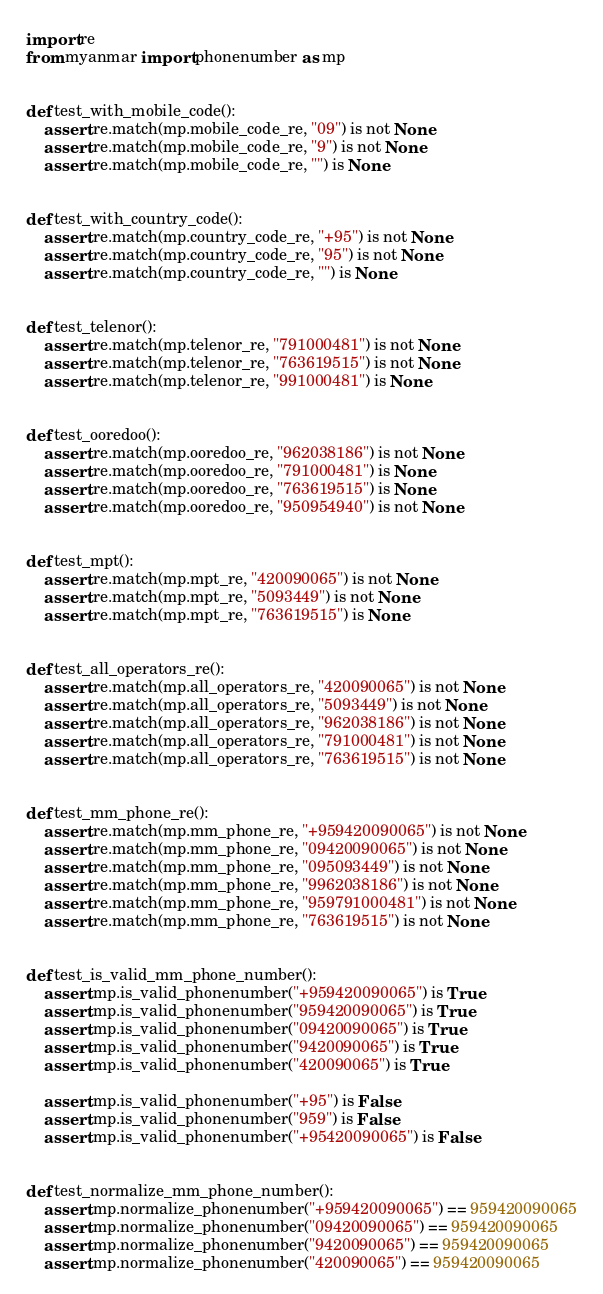Convert code to text. <code><loc_0><loc_0><loc_500><loc_500><_Python_>import re
from myanmar import phonenumber as mp


def test_with_mobile_code():
    assert re.match(mp.mobile_code_re, "09") is not None
    assert re.match(mp.mobile_code_re, "9") is not None
    assert re.match(mp.mobile_code_re, "") is None


def test_with_country_code():
    assert re.match(mp.country_code_re, "+95") is not None
    assert re.match(mp.country_code_re, "95") is not None
    assert re.match(mp.country_code_re, "") is None


def test_telenor():
    assert re.match(mp.telenor_re, "791000481") is not None
    assert re.match(mp.telenor_re, "763619515") is not None
    assert re.match(mp.telenor_re, "991000481") is None


def test_ooredoo():
    assert re.match(mp.ooredoo_re, "962038186") is not None
    assert re.match(mp.ooredoo_re, "791000481") is None
    assert re.match(mp.ooredoo_re, "763619515") is None
    assert re.match(mp.ooredoo_re, "950954940") is not None


def test_mpt():
    assert re.match(mp.mpt_re, "420090065") is not None
    assert re.match(mp.mpt_re, "5093449") is not None
    assert re.match(mp.mpt_re, "763619515") is None


def test_all_operators_re():
    assert re.match(mp.all_operators_re, "420090065") is not None
    assert re.match(mp.all_operators_re, "5093449") is not None
    assert re.match(mp.all_operators_re, "962038186") is not None
    assert re.match(mp.all_operators_re, "791000481") is not None
    assert re.match(mp.all_operators_re, "763619515") is not None


def test_mm_phone_re():
    assert re.match(mp.mm_phone_re, "+959420090065") is not None
    assert re.match(mp.mm_phone_re, "09420090065") is not None
    assert re.match(mp.mm_phone_re, "095093449") is not None
    assert re.match(mp.mm_phone_re, "9962038186") is not None
    assert re.match(mp.mm_phone_re, "959791000481") is not None
    assert re.match(mp.mm_phone_re, "763619515") is not None


def test_is_valid_mm_phone_number():
    assert mp.is_valid_phonenumber("+959420090065") is True
    assert mp.is_valid_phonenumber("959420090065") is True
    assert mp.is_valid_phonenumber("09420090065") is True
    assert mp.is_valid_phonenumber("9420090065") is True
    assert mp.is_valid_phonenumber("420090065") is True

    assert mp.is_valid_phonenumber("+95") is False
    assert mp.is_valid_phonenumber("959") is False
    assert mp.is_valid_phonenumber("+95420090065") is False


def test_normalize_mm_phone_number():
    assert mp.normalize_phonenumber("+959420090065") == 959420090065
    assert mp.normalize_phonenumber("09420090065") == 959420090065
    assert mp.normalize_phonenumber("9420090065") == 959420090065
    assert mp.normalize_phonenumber("420090065") == 959420090065
</code> 